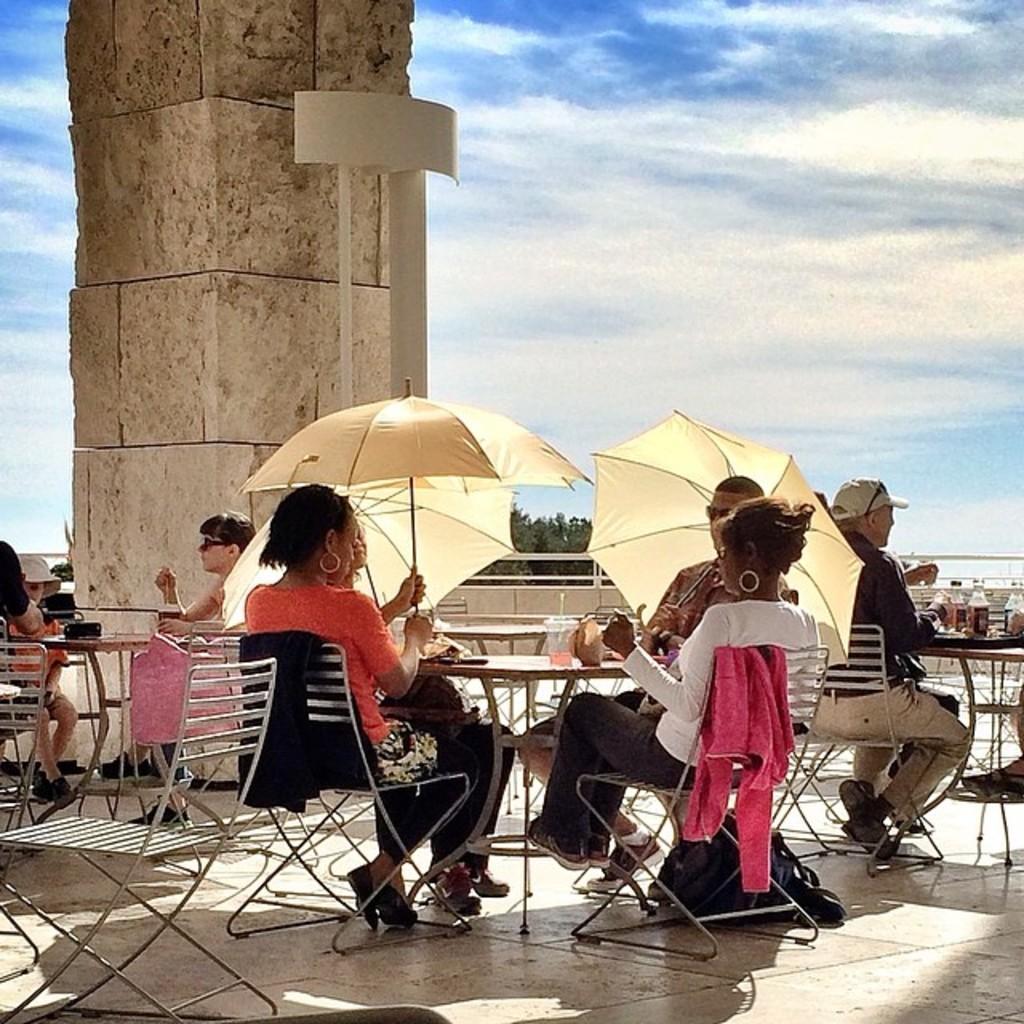How would you summarize this image in a sentence or two? The picture is taken in a restaurant. In the foreground of the picture there are tables, chairs, bottles, food items, umbrellas and people. On the left there is a pillar. Sky is bit cloudy and it is sunny. In the background there are trees. 